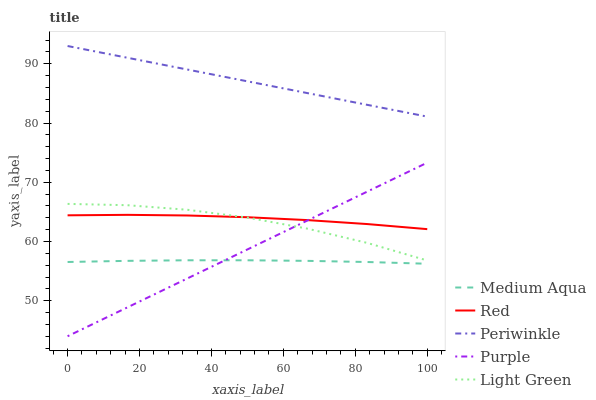Does Medium Aqua have the minimum area under the curve?
Answer yes or no. Yes. Does Periwinkle have the maximum area under the curve?
Answer yes or no. Yes. Does Periwinkle have the minimum area under the curve?
Answer yes or no. No. Does Medium Aqua have the maximum area under the curve?
Answer yes or no. No. Is Purple the smoothest?
Answer yes or no. Yes. Is Light Green the roughest?
Answer yes or no. Yes. Is Periwinkle the smoothest?
Answer yes or no. No. Is Periwinkle the roughest?
Answer yes or no. No. Does Purple have the lowest value?
Answer yes or no. Yes. Does Medium Aqua have the lowest value?
Answer yes or no. No. Does Periwinkle have the highest value?
Answer yes or no. Yes. Does Medium Aqua have the highest value?
Answer yes or no. No. Is Medium Aqua less than Red?
Answer yes or no. Yes. Is Periwinkle greater than Medium Aqua?
Answer yes or no. Yes. Does Red intersect Light Green?
Answer yes or no. Yes. Is Red less than Light Green?
Answer yes or no. No. Is Red greater than Light Green?
Answer yes or no. No. Does Medium Aqua intersect Red?
Answer yes or no. No. 